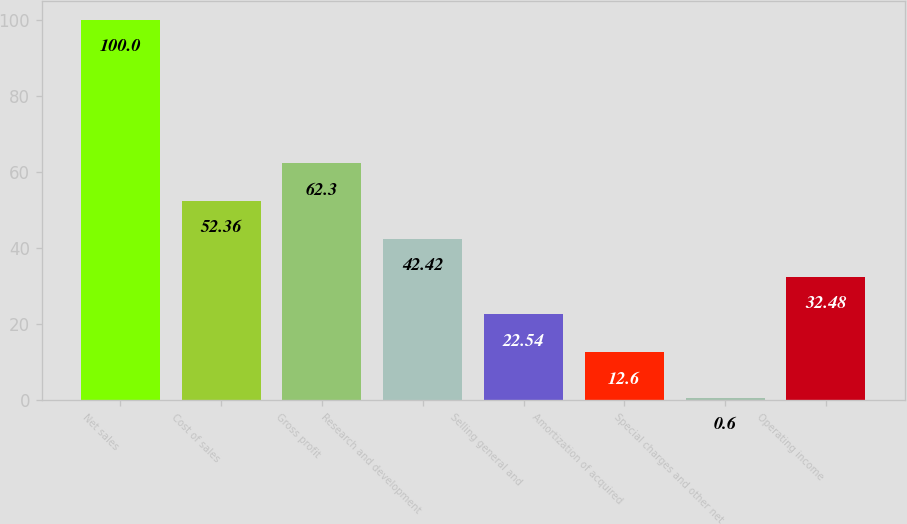Convert chart to OTSL. <chart><loc_0><loc_0><loc_500><loc_500><bar_chart><fcel>Net sales<fcel>Cost of sales<fcel>Gross profit<fcel>Research and development<fcel>Selling general and<fcel>Amortization of acquired<fcel>Special charges and other net<fcel>Operating income<nl><fcel>100<fcel>52.36<fcel>62.3<fcel>42.42<fcel>22.54<fcel>12.6<fcel>0.6<fcel>32.48<nl></chart> 